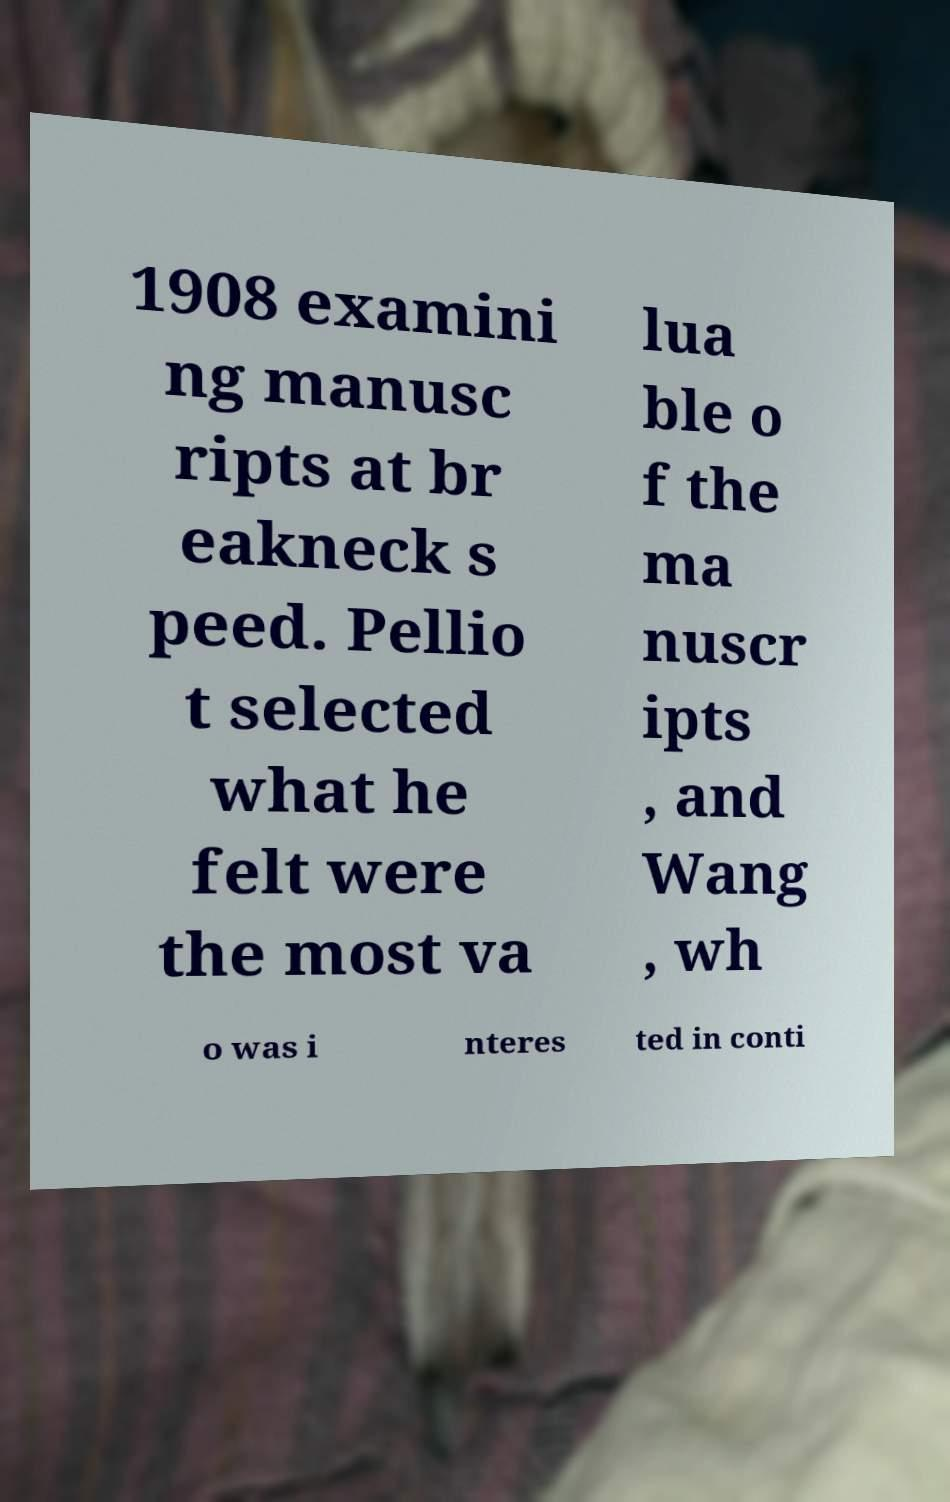There's text embedded in this image that I need extracted. Can you transcribe it verbatim? 1908 examini ng manusc ripts at br eakneck s peed. Pellio t selected what he felt were the most va lua ble o f the ma nuscr ipts , and Wang , wh o was i nteres ted in conti 